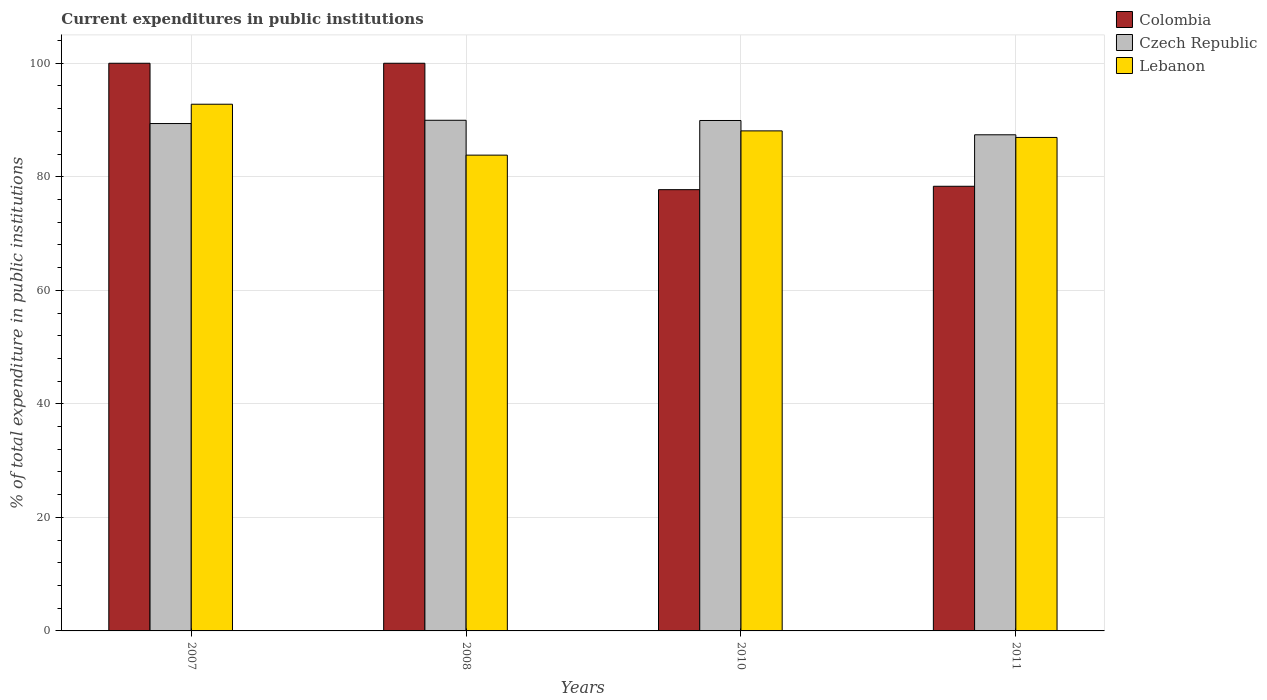How many groups of bars are there?
Your answer should be very brief. 4. Are the number of bars per tick equal to the number of legend labels?
Keep it short and to the point. Yes. Are the number of bars on each tick of the X-axis equal?
Provide a succinct answer. Yes. How many bars are there on the 1st tick from the left?
Offer a terse response. 3. What is the current expenditures in public institutions in Colombia in 2007?
Your answer should be very brief. 100. Across all years, what is the maximum current expenditures in public institutions in Colombia?
Keep it short and to the point. 100. Across all years, what is the minimum current expenditures in public institutions in Czech Republic?
Your answer should be very brief. 87.4. In which year was the current expenditures in public institutions in Colombia maximum?
Ensure brevity in your answer.  2007. What is the total current expenditures in public institutions in Colombia in the graph?
Give a very brief answer. 356.06. What is the difference between the current expenditures in public institutions in Lebanon in 2007 and that in 2011?
Provide a succinct answer. 5.85. What is the difference between the current expenditures in public institutions in Lebanon in 2011 and the current expenditures in public institutions in Czech Republic in 2008?
Ensure brevity in your answer.  -3.02. What is the average current expenditures in public institutions in Czech Republic per year?
Your answer should be very brief. 89.16. In the year 2011, what is the difference between the current expenditures in public institutions in Lebanon and current expenditures in public institutions in Czech Republic?
Provide a succinct answer. -0.47. What is the ratio of the current expenditures in public institutions in Lebanon in 2007 to that in 2011?
Your response must be concise. 1.07. What is the difference between the highest and the second highest current expenditures in public institutions in Czech Republic?
Keep it short and to the point. 0.04. What is the difference between the highest and the lowest current expenditures in public institutions in Czech Republic?
Provide a short and direct response. 2.56. In how many years, is the current expenditures in public institutions in Colombia greater than the average current expenditures in public institutions in Colombia taken over all years?
Make the answer very short. 2. Is the sum of the current expenditures in public institutions in Czech Republic in 2007 and 2008 greater than the maximum current expenditures in public institutions in Colombia across all years?
Your answer should be compact. Yes. What does the 1st bar from the left in 2007 represents?
Make the answer very short. Colombia. What does the 2nd bar from the right in 2007 represents?
Your answer should be very brief. Czech Republic. Is it the case that in every year, the sum of the current expenditures in public institutions in Colombia and current expenditures in public institutions in Czech Republic is greater than the current expenditures in public institutions in Lebanon?
Keep it short and to the point. Yes. How many bars are there?
Ensure brevity in your answer.  12. How many years are there in the graph?
Keep it short and to the point. 4. What is the difference between two consecutive major ticks on the Y-axis?
Your answer should be compact. 20. Are the values on the major ticks of Y-axis written in scientific E-notation?
Offer a terse response. No. How many legend labels are there?
Provide a short and direct response. 3. What is the title of the graph?
Offer a very short reply. Current expenditures in public institutions. What is the label or title of the X-axis?
Give a very brief answer. Years. What is the label or title of the Y-axis?
Your response must be concise. % of total expenditure in public institutions. What is the % of total expenditure in public institutions in Czech Republic in 2007?
Provide a succinct answer. 89.38. What is the % of total expenditure in public institutions in Lebanon in 2007?
Provide a succinct answer. 92.78. What is the % of total expenditure in public institutions in Czech Republic in 2008?
Your answer should be compact. 89.96. What is the % of total expenditure in public institutions in Lebanon in 2008?
Provide a succinct answer. 83.82. What is the % of total expenditure in public institutions of Colombia in 2010?
Give a very brief answer. 77.73. What is the % of total expenditure in public institutions of Czech Republic in 2010?
Offer a very short reply. 89.92. What is the % of total expenditure in public institutions in Lebanon in 2010?
Keep it short and to the point. 88.09. What is the % of total expenditure in public institutions of Colombia in 2011?
Offer a very short reply. 78.33. What is the % of total expenditure in public institutions of Czech Republic in 2011?
Give a very brief answer. 87.4. What is the % of total expenditure in public institutions of Lebanon in 2011?
Your answer should be compact. 86.93. Across all years, what is the maximum % of total expenditure in public institutions in Colombia?
Provide a succinct answer. 100. Across all years, what is the maximum % of total expenditure in public institutions of Czech Republic?
Offer a terse response. 89.96. Across all years, what is the maximum % of total expenditure in public institutions in Lebanon?
Offer a terse response. 92.78. Across all years, what is the minimum % of total expenditure in public institutions of Colombia?
Your answer should be very brief. 77.73. Across all years, what is the minimum % of total expenditure in public institutions of Czech Republic?
Your answer should be very brief. 87.4. Across all years, what is the minimum % of total expenditure in public institutions of Lebanon?
Keep it short and to the point. 83.82. What is the total % of total expenditure in public institutions of Colombia in the graph?
Your answer should be compact. 356.06. What is the total % of total expenditure in public institutions of Czech Republic in the graph?
Your answer should be compact. 356.65. What is the total % of total expenditure in public institutions of Lebanon in the graph?
Provide a succinct answer. 351.62. What is the difference between the % of total expenditure in public institutions of Czech Republic in 2007 and that in 2008?
Offer a terse response. -0.57. What is the difference between the % of total expenditure in public institutions in Lebanon in 2007 and that in 2008?
Give a very brief answer. 8.97. What is the difference between the % of total expenditure in public institutions of Colombia in 2007 and that in 2010?
Ensure brevity in your answer.  22.27. What is the difference between the % of total expenditure in public institutions of Czech Republic in 2007 and that in 2010?
Keep it short and to the point. -0.54. What is the difference between the % of total expenditure in public institutions of Lebanon in 2007 and that in 2010?
Your answer should be very brief. 4.69. What is the difference between the % of total expenditure in public institutions in Colombia in 2007 and that in 2011?
Give a very brief answer. 21.67. What is the difference between the % of total expenditure in public institutions in Czech Republic in 2007 and that in 2011?
Give a very brief answer. 1.98. What is the difference between the % of total expenditure in public institutions of Lebanon in 2007 and that in 2011?
Provide a succinct answer. 5.85. What is the difference between the % of total expenditure in public institutions of Colombia in 2008 and that in 2010?
Provide a succinct answer. 22.27. What is the difference between the % of total expenditure in public institutions of Czech Republic in 2008 and that in 2010?
Provide a succinct answer. 0.04. What is the difference between the % of total expenditure in public institutions of Lebanon in 2008 and that in 2010?
Offer a very short reply. -4.27. What is the difference between the % of total expenditure in public institutions in Colombia in 2008 and that in 2011?
Keep it short and to the point. 21.67. What is the difference between the % of total expenditure in public institutions in Czech Republic in 2008 and that in 2011?
Ensure brevity in your answer.  2.56. What is the difference between the % of total expenditure in public institutions in Lebanon in 2008 and that in 2011?
Provide a succinct answer. -3.12. What is the difference between the % of total expenditure in public institutions of Colombia in 2010 and that in 2011?
Offer a very short reply. -0.6. What is the difference between the % of total expenditure in public institutions of Czech Republic in 2010 and that in 2011?
Provide a succinct answer. 2.52. What is the difference between the % of total expenditure in public institutions of Lebanon in 2010 and that in 2011?
Give a very brief answer. 1.16. What is the difference between the % of total expenditure in public institutions in Colombia in 2007 and the % of total expenditure in public institutions in Czech Republic in 2008?
Give a very brief answer. 10.04. What is the difference between the % of total expenditure in public institutions of Colombia in 2007 and the % of total expenditure in public institutions of Lebanon in 2008?
Ensure brevity in your answer.  16.18. What is the difference between the % of total expenditure in public institutions in Czech Republic in 2007 and the % of total expenditure in public institutions in Lebanon in 2008?
Your response must be concise. 5.57. What is the difference between the % of total expenditure in public institutions of Colombia in 2007 and the % of total expenditure in public institutions of Czech Republic in 2010?
Give a very brief answer. 10.08. What is the difference between the % of total expenditure in public institutions in Colombia in 2007 and the % of total expenditure in public institutions in Lebanon in 2010?
Make the answer very short. 11.91. What is the difference between the % of total expenditure in public institutions in Czech Republic in 2007 and the % of total expenditure in public institutions in Lebanon in 2010?
Give a very brief answer. 1.29. What is the difference between the % of total expenditure in public institutions in Colombia in 2007 and the % of total expenditure in public institutions in Czech Republic in 2011?
Make the answer very short. 12.6. What is the difference between the % of total expenditure in public institutions of Colombia in 2007 and the % of total expenditure in public institutions of Lebanon in 2011?
Your answer should be compact. 13.07. What is the difference between the % of total expenditure in public institutions of Czech Republic in 2007 and the % of total expenditure in public institutions of Lebanon in 2011?
Make the answer very short. 2.45. What is the difference between the % of total expenditure in public institutions of Colombia in 2008 and the % of total expenditure in public institutions of Czech Republic in 2010?
Provide a short and direct response. 10.08. What is the difference between the % of total expenditure in public institutions of Colombia in 2008 and the % of total expenditure in public institutions of Lebanon in 2010?
Keep it short and to the point. 11.91. What is the difference between the % of total expenditure in public institutions of Czech Republic in 2008 and the % of total expenditure in public institutions of Lebanon in 2010?
Your answer should be very brief. 1.87. What is the difference between the % of total expenditure in public institutions in Colombia in 2008 and the % of total expenditure in public institutions in Czech Republic in 2011?
Your answer should be very brief. 12.6. What is the difference between the % of total expenditure in public institutions of Colombia in 2008 and the % of total expenditure in public institutions of Lebanon in 2011?
Give a very brief answer. 13.07. What is the difference between the % of total expenditure in public institutions in Czech Republic in 2008 and the % of total expenditure in public institutions in Lebanon in 2011?
Offer a very short reply. 3.02. What is the difference between the % of total expenditure in public institutions in Colombia in 2010 and the % of total expenditure in public institutions in Czech Republic in 2011?
Keep it short and to the point. -9.67. What is the difference between the % of total expenditure in public institutions in Colombia in 2010 and the % of total expenditure in public institutions in Lebanon in 2011?
Keep it short and to the point. -9.2. What is the difference between the % of total expenditure in public institutions of Czech Republic in 2010 and the % of total expenditure in public institutions of Lebanon in 2011?
Offer a terse response. 2.98. What is the average % of total expenditure in public institutions in Colombia per year?
Make the answer very short. 89.02. What is the average % of total expenditure in public institutions in Czech Republic per year?
Give a very brief answer. 89.16. What is the average % of total expenditure in public institutions in Lebanon per year?
Ensure brevity in your answer.  87.9. In the year 2007, what is the difference between the % of total expenditure in public institutions of Colombia and % of total expenditure in public institutions of Czech Republic?
Your answer should be compact. 10.62. In the year 2007, what is the difference between the % of total expenditure in public institutions of Colombia and % of total expenditure in public institutions of Lebanon?
Ensure brevity in your answer.  7.22. In the year 2007, what is the difference between the % of total expenditure in public institutions in Czech Republic and % of total expenditure in public institutions in Lebanon?
Provide a short and direct response. -3.4. In the year 2008, what is the difference between the % of total expenditure in public institutions in Colombia and % of total expenditure in public institutions in Czech Republic?
Offer a terse response. 10.04. In the year 2008, what is the difference between the % of total expenditure in public institutions in Colombia and % of total expenditure in public institutions in Lebanon?
Your answer should be compact. 16.18. In the year 2008, what is the difference between the % of total expenditure in public institutions in Czech Republic and % of total expenditure in public institutions in Lebanon?
Give a very brief answer. 6.14. In the year 2010, what is the difference between the % of total expenditure in public institutions of Colombia and % of total expenditure in public institutions of Czech Republic?
Your answer should be compact. -12.18. In the year 2010, what is the difference between the % of total expenditure in public institutions of Colombia and % of total expenditure in public institutions of Lebanon?
Your answer should be very brief. -10.36. In the year 2010, what is the difference between the % of total expenditure in public institutions of Czech Republic and % of total expenditure in public institutions of Lebanon?
Ensure brevity in your answer.  1.83. In the year 2011, what is the difference between the % of total expenditure in public institutions in Colombia and % of total expenditure in public institutions in Czech Republic?
Ensure brevity in your answer.  -9.07. In the year 2011, what is the difference between the % of total expenditure in public institutions in Colombia and % of total expenditure in public institutions in Lebanon?
Offer a very short reply. -8.6. In the year 2011, what is the difference between the % of total expenditure in public institutions of Czech Republic and % of total expenditure in public institutions of Lebanon?
Provide a succinct answer. 0.47. What is the ratio of the % of total expenditure in public institutions of Colombia in 2007 to that in 2008?
Your answer should be very brief. 1. What is the ratio of the % of total expenditure in public institutions of Czech Republic in 2007 to that in 2008?
Make the answer very short. 0.99. What is the ratio of the % of total expenditure in public institutions in Lebanon in 2007 to that in 2008?
Make the answer very short. 1.11. What is the ratio of the % of total expenditure in public institutions of Colombia in 2007 to that in 2010?
Provide a short and direct response. 1.29. What is the ratio of the % of total expenditure in public institutions in Lebanon in 2007 to that in 2010?
Provide a short and direct response. 1.05. What is the ratio of the % of total expenditure in public institutions of Colombia in 2007 to that in 2011?
Make the answer very short. 1.28. What is the ratio of the % of total expenditure in public institutions of Czech Republic in 2007 to that in 2011?
Offer a terse response. 1.02. What is the ratio of the % of total expenditure in public institutions of Lebanon in 2007 to that in 2011?
Keep it short and to the point. 1.07. What is the ratio of the % of total expenditure in public institutions of Colombia in 2008 to that in 2010?
Offer a very short reply. 1.29. What is the ratio of the % of total expenditure in public institutions in Czech Republic in 2008 to that in 2010?
Give a very brief answer. 1. What is the ratio of the % of total expenditure in public institutions in Lebanon in 2008 to that in 2010?
Your answer should be very brief. 0.95. What is the ratio of the % of total expenditure in public institutions in Colombia in 2008 to that in 2011?
Provide a succinct answer. 1.28. What is the ratio of the % of total expenditure in public institutions in Czech Republic in 2008 to that in 2011?
Your response must be concise. 1.03. What is the ratio of the % of total expenditure in public institutions in Lebanon in 2008 to that in 2011?
Your answer should be very brief. 0.96. What is the ratio of the % of total expenditure in public institutions of Colombia in 2010 to that in 2011?
Provide a short and direct response. 0.99. What is the ratio of the % of total expenditure in public institutions of Czech Republic in 2010 to that in 2011?
Keep it short and to the point. 1.03. What is the ratio of the % of total expenditure in public institutions of Lebanon in 2010 to that in 2011?
Make the answer very short. 1.01. What is the difference between the highest and the second highest % of total expenditure in public institutions in Colombia?
Provide a succinct answer. 0. What is the difference between the highest and the second highest % of total expenditure in public institutions of Czech Republic?
Offer a very short reply. 0.04. What is the difference between the highest and the second highest % of total expenditure in public institutions in Lebanon?
Offer a very short reply. 4.69. What is the difference between the highest and the lowest % of total expenditure in public institutions in Colombia?
Keep it short and to the point. 22.27. What is the difference between the highest and the lowest % of total expenditure in public institutions of Czech Republic?
Make the answer very short. 2.56. What is the difference between the highest and the lowest % of total expenditure in public institutions in Lebanon?
Make the answer very short. 8.97. 